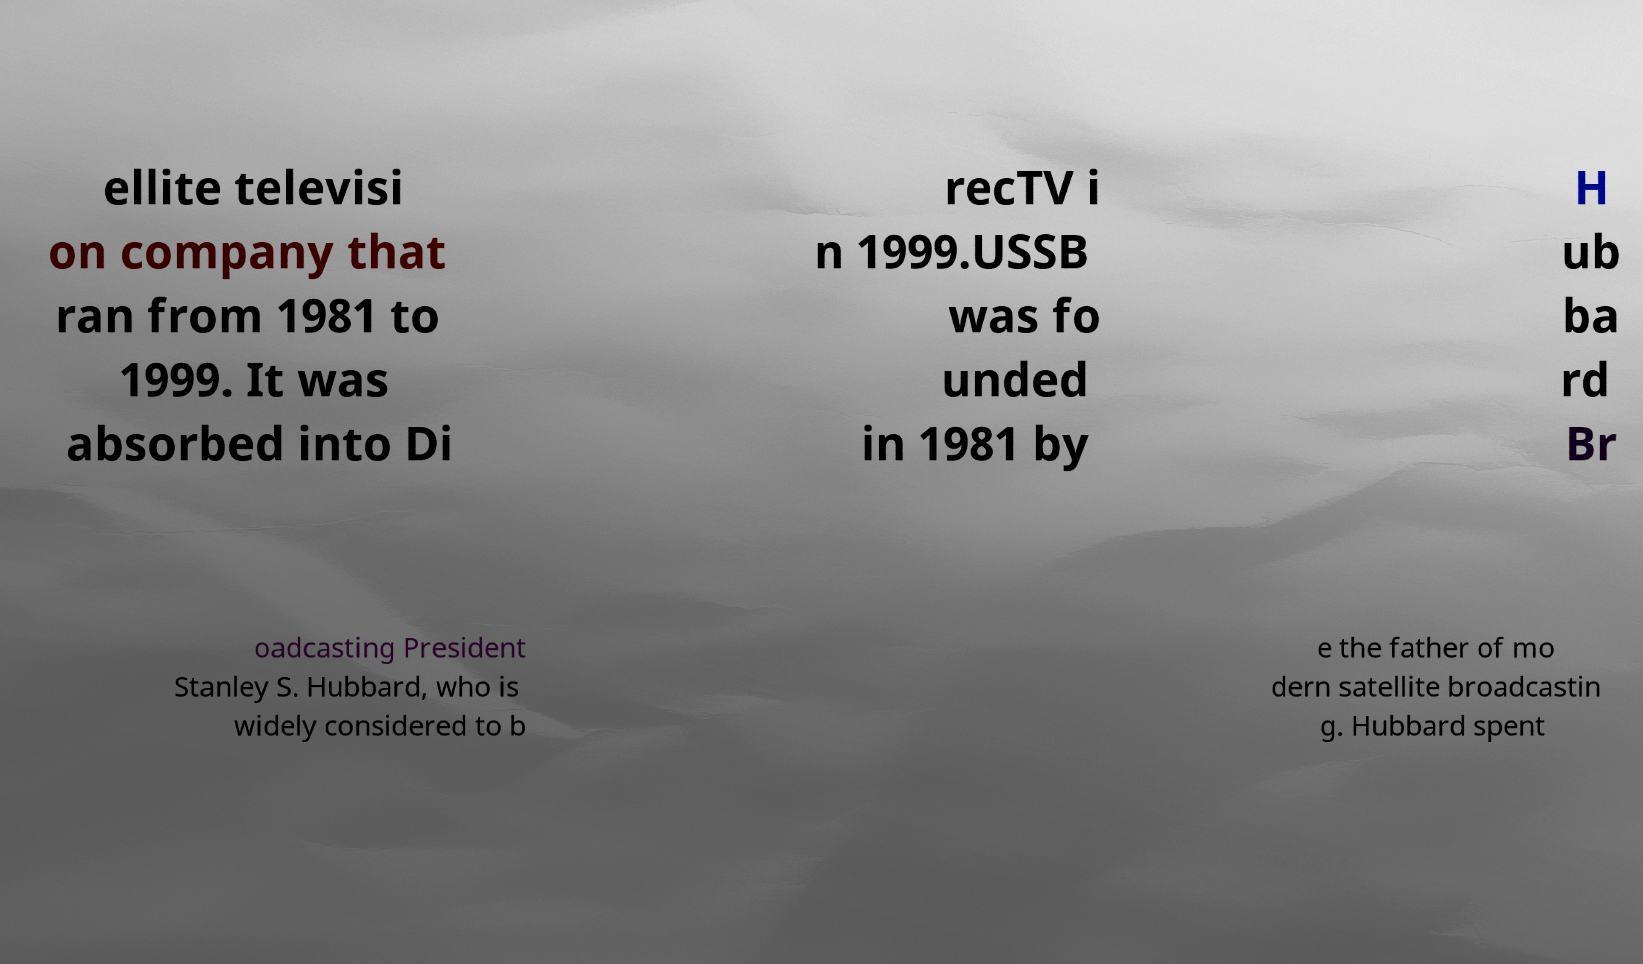What messages or text are displayed in this image? I need them in a readable, typed format. ellite televisi on company that ran from 1981 to 1999. It was absorbed into Di recTV i n 1999.USSB was fo unded in 1981 by H ub ba rd Br oadcasting President Stanley S. Hubbard, who is widely considered to b e the father of mo dern satellite broadcastin g. Hubbard spent 